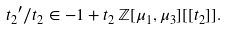<formula> <loc_0><loc_0><loc_500><loc_500>{ t _ { 2 } } ^ { \prime } / t _ { 2 } \in - 1 + t _ { 2 } \, \mathbb { Z } [ \mu _ { 1 } , \mu _ { 3 } ] [ [ t _ { 2 } ] ] .</formula> 